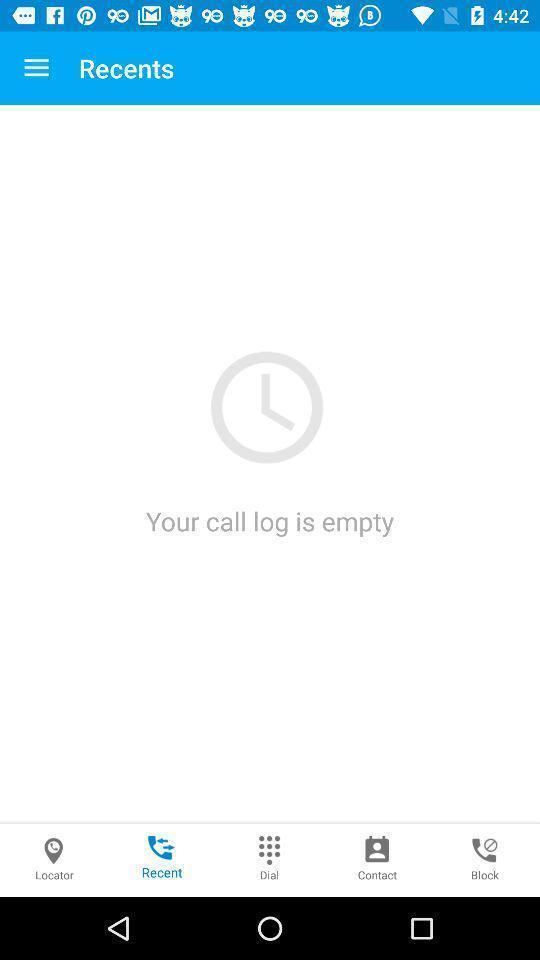Tell me about the visual elements in this screen capture. Page showing your call log is empty. 